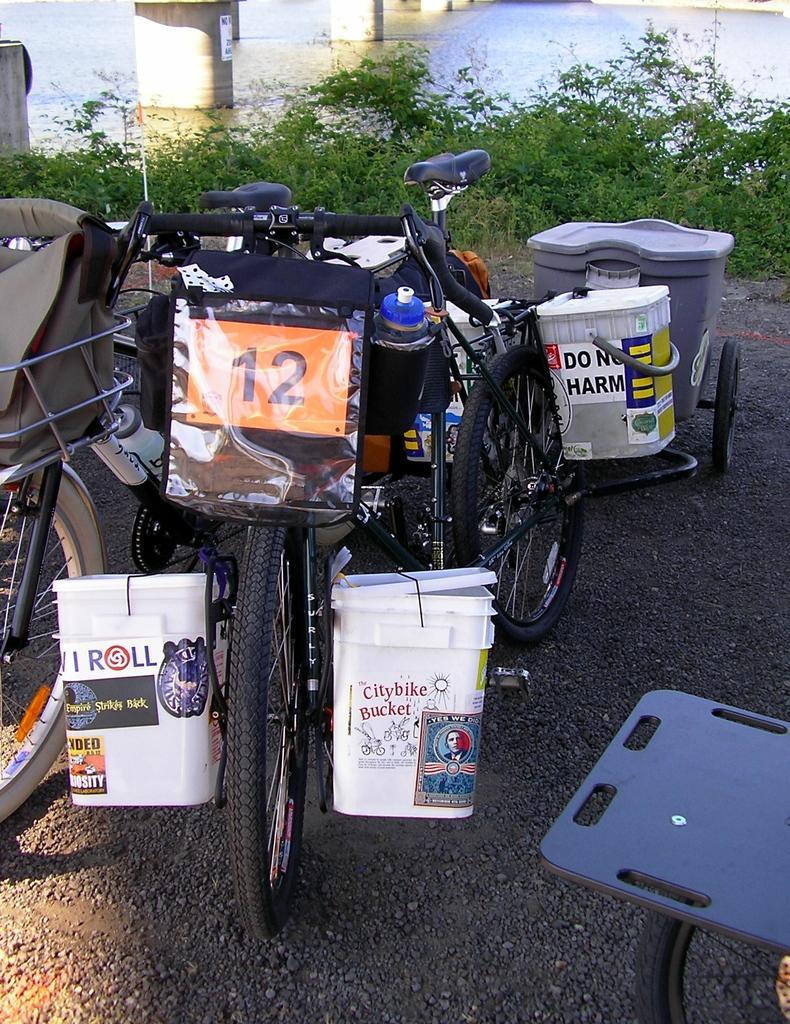Please provide a concise description of this image. In this image there are a few bicycles with some luggages on it, which are on the road, behind them there are plants and we can see pillars in the water. 